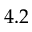<formula> <loc_0><loc_0><loc_500><loc_500>4 . 2</formula> 